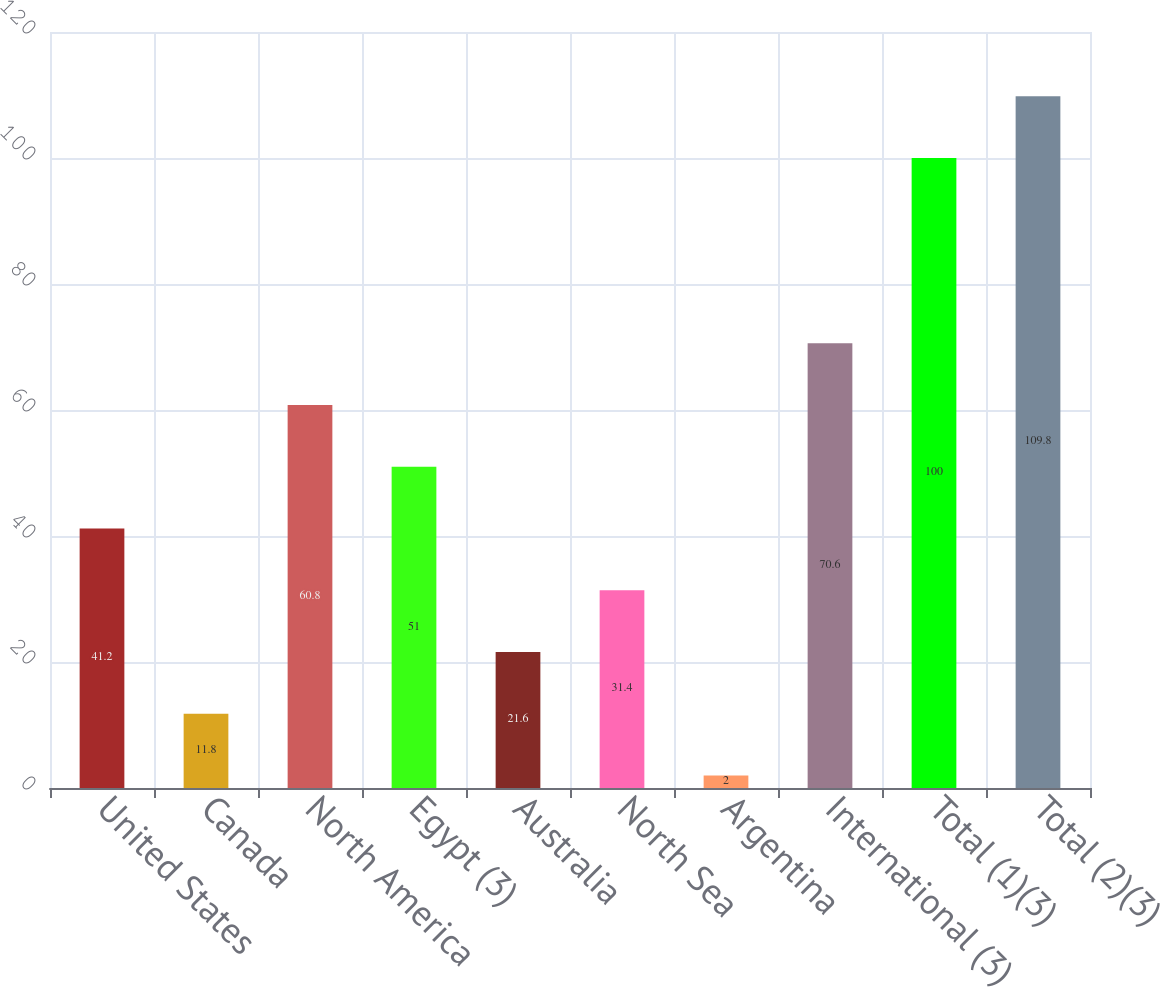Convert chart to OTSL. <chart><loc_0><loc_0><loc_500><loc_500><bar_chart><fcel>United States<fcel>Canada<fcel>North America<fcel>Egypt (3)<fcel>Australia<fcel>North Sea<fcel>Argentina<fcel>International (3)<fcel>Total (1)(3)<fcel>Total (2)(3)<nl><fcel>41.2<fcel>11.8<fcel>60.8<fcel>51<fcel>21.6<fcel>31.4<fcel>2<fcel>70.6<fcel>100<fcel>109.8<nl></chart> 